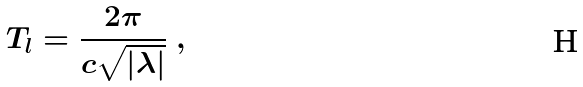<formula> <loc_0><loc_0><loc_500><loc_500>T _ { l } = \frac { 2 \pi } { c \sqrt { | \lambda | } } \ ,</formula> 